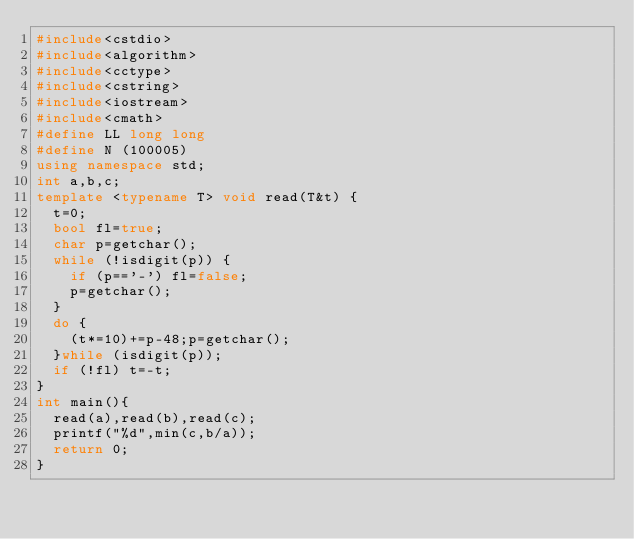<code> <loc_0><loc_0><loc_500><loc_500><_C++_>#include<cstdio>
#include<algorithm>
#include<cctype>
#include<cstring>
#include<iostream>
#include<cmath>
#define LL long long
#define N (100005)
using namespace std;
int a,b,c; 
template <typename T> void read(T&t) {
	t=0;
	bool fl=true;
	char p=getchar();
	while (!isdigit(p)) {
		if (p=='-') fl=false;
		p=getchar();
	}
	do {
		(t*=10)+=p-48;p=getchar();
	}while (isdigit(p));
	if (!fl) t=-t;
}
int main(){
	read(a),read(b),read(c);
	printf("%d",min(c,b/a));
	return 0;
}
</code> 